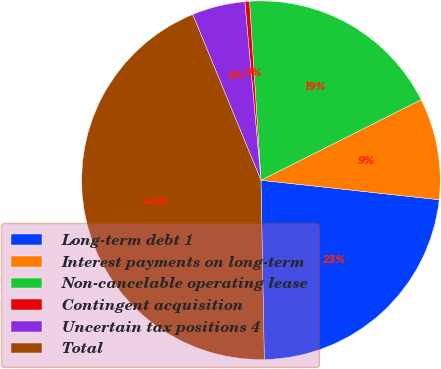Convert chart. <chart><loc_0><loc_0><loc_500><loc_500><pie_chart><fcel>Long-term debt 1<fcel>Interest payments on long-term<fcel>Non-cancelable operating lease<fcel>Contingent acquisition<fcel>Uncertain tax positions 4<fcel>Total<nl><fcel>22.97%<fcel>9.15%<fcel>18.6%<fcel>0.42%<fcel>4.78%<fcel>44.08%<nl></chart> 